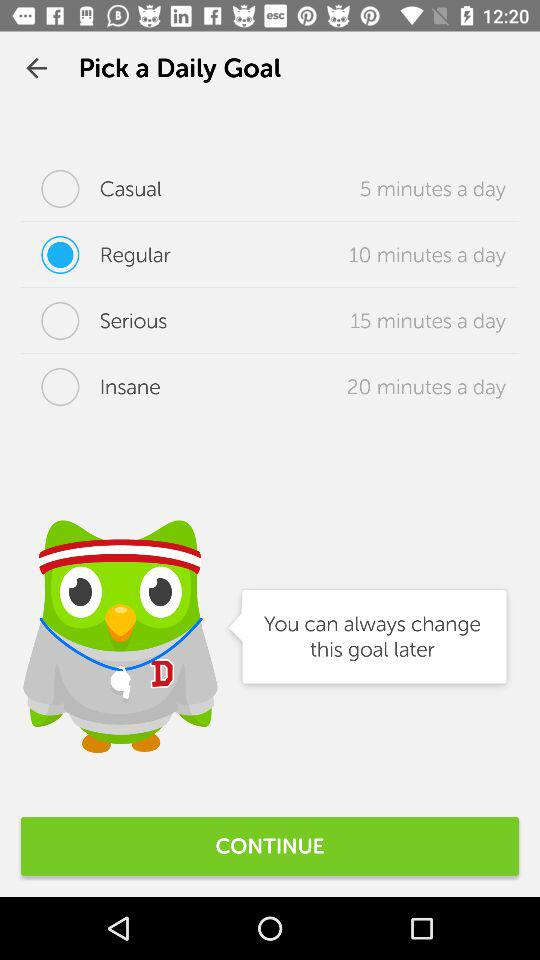Which daily goal option requires spending 20 minutes a day? The daily goal option that requires spending 20 minutes a day is "Insane". 